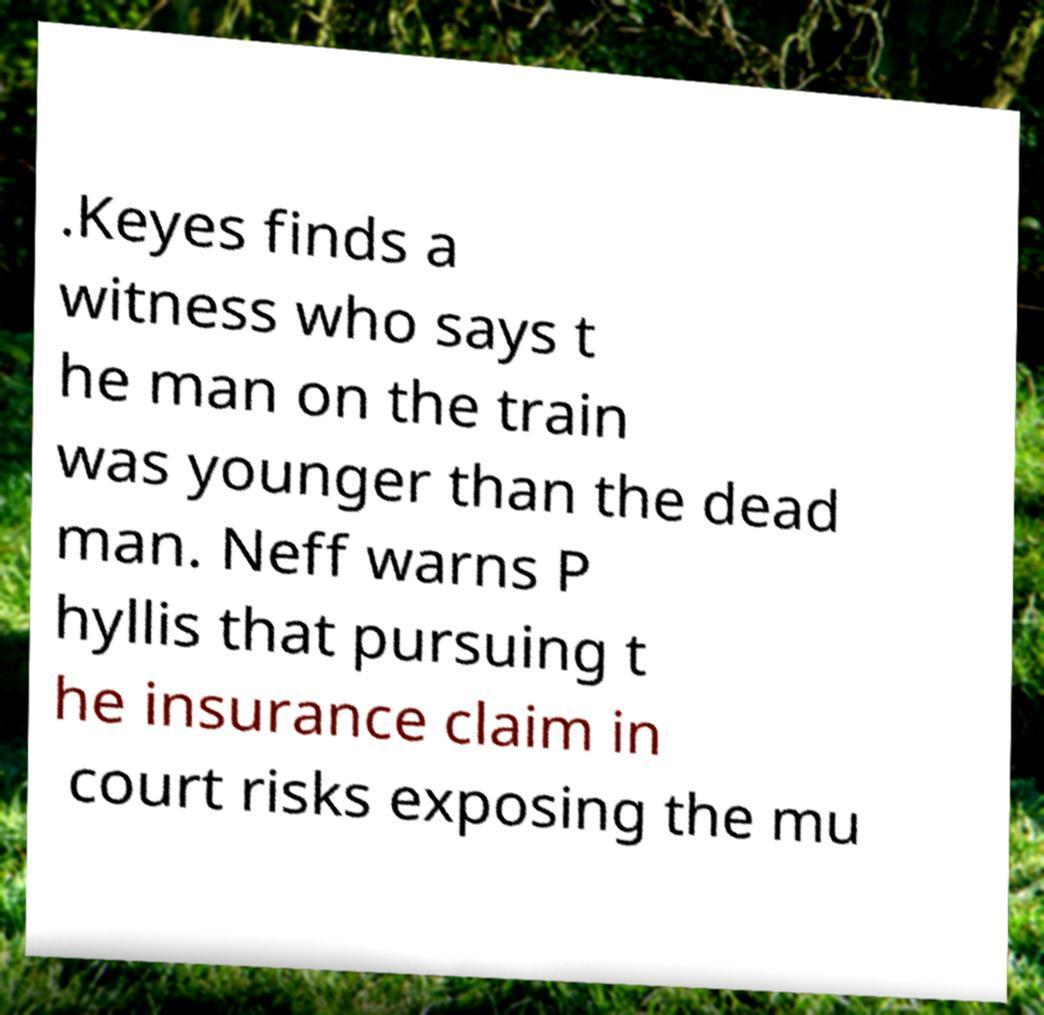For documentation purposes, I need the text within this image transcribed. Could you provide that? .Keyes finds a witness who says t he man on the train was younger than the dead man. Neff warns P hyllis that pursuing t he insurance claim in court risks exposing the mu 